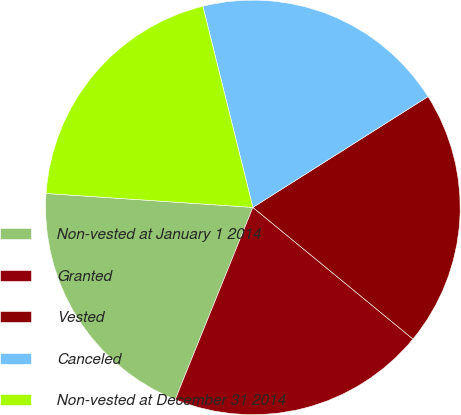<chart> <loc_0><loc_0><loc_500><loc_500><pie_chart><fcel>Non-vested at January 1 2014<fcel>Granted<fcel>Vested<fcel>Canceled<fcel>Non-vested at December 31 2014<nl><fcel>19.96%<fcel>20.16%<fcel>19.93%<fcel>19.9%<fcel>20.05%<nl></chart> 